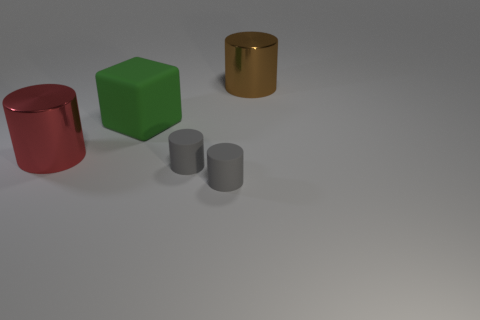Is the material of the large cylinder in front of the large brown cylinder the same as the green object right of the large red cylinder?
Give a very brief answer. No. There is a red object that is the same size as the green rubber block; what shape is it?
Your answer should be very brief. Cylinder. Is the number of cylinders less than the number of big gray shiny balls?
Offer a terse response. No. Is there a red cylinder left of the big cylinder that is in front of the big green matte block?
Provide a succinct answer. No. There is a metal cylinder left of the brown cylinder to the right of the large block; is there a large red cylinder that is to the right of it?
Keep it short and to the point. No. Does the large shiny thing behind the red shiny object have the same shape as the metal object that is in front of the green rubber object?
Make the answer very short. Yes. The other big cylinder that is the same material as the red cylinder is what color?
Your answer should be compact. Brown. Are there fewer brown metal cylinders that are behind the red cylinder than red metal things?
Offer a very short reply. No. Do the large cylinder behind the big red object and the cube have the same material?
Offer a terse response. No. Is there anything else that has the same shape as the big matte object?
Your answer should be very brief. No. 